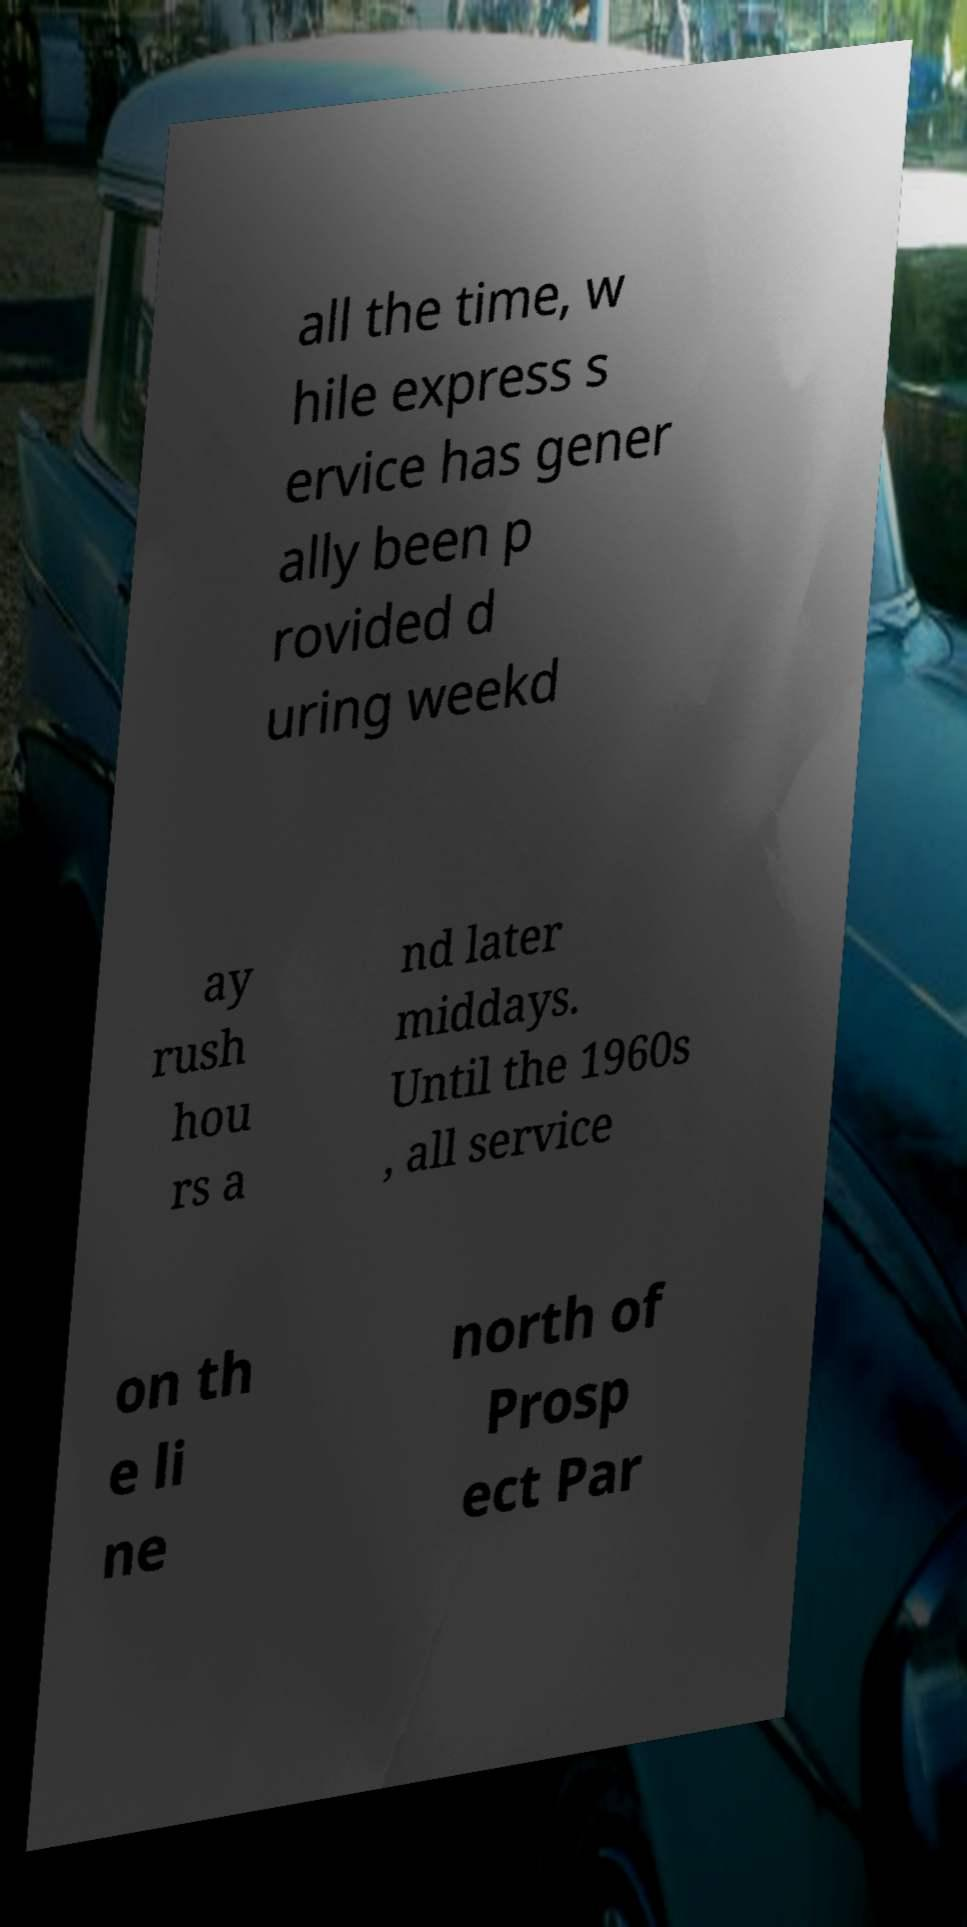Can you read and provide the text displayed in the image?This photo seems to have some interesting text. Can you extract and type it out for me? all the time, w hile express s ervice has gener ally been p rovided d uring weekd ay rush hou rs a nd later middays. Until the 1960s , all service on th e li ne north of Prosp ect Par 